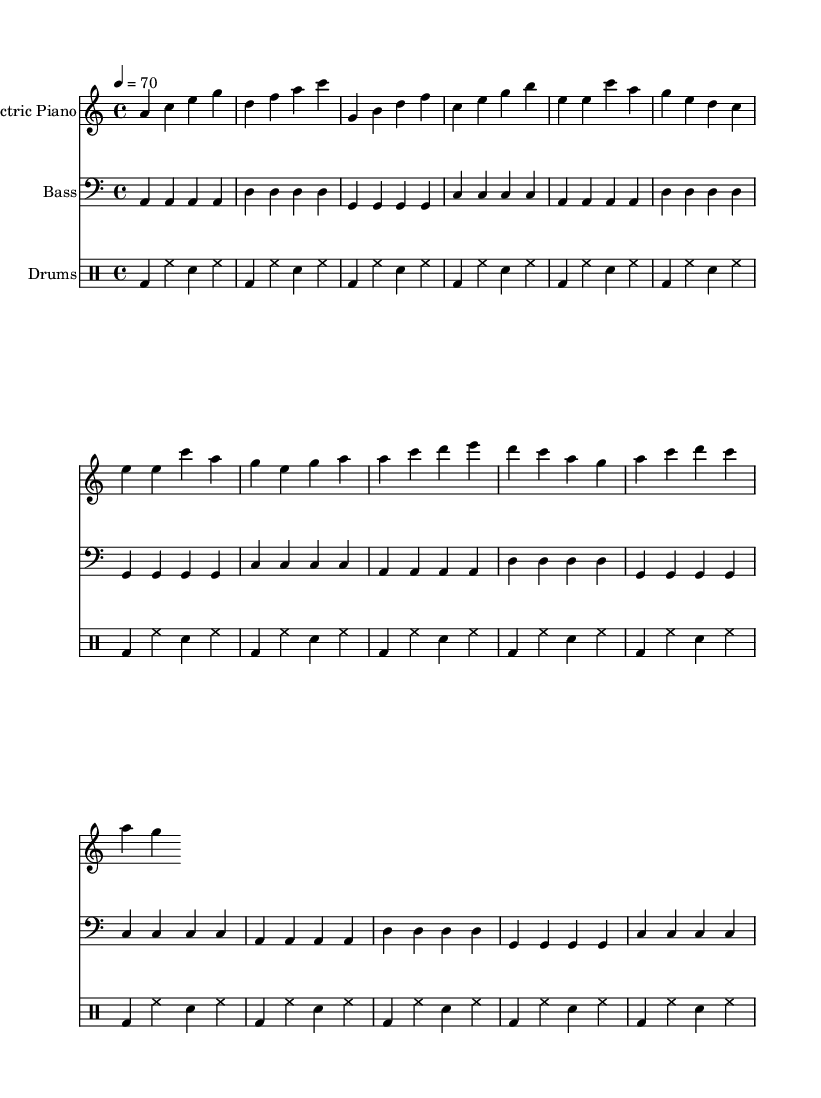What is the key signature of this music? The key signature is A minor, which has no sharps or flats.
Answer: A minor What is the time signature of the music? The time signature is 4/4, indicating four beats per measure.
Answer: 4/4 What is the tempo marking for this piece? The tempo marking is quarter note equals 70, meaning there are 70 beats in a minute.
Answer: 70 How many measures are in the verse section? The verse section contains 8 measures, as indicated by the notation in that part of the sheet music.
Answer: 8 What instrument plays the main melodic line in this piece? The electric piano plays the main melodic line, as it is shown prominently in the treble clef staff.
Answer: Electric Piano What rhythmic pattern do the drums primarily use? The drums use a basic 4-bar pattern of bass and snare with hi-hat, typical in R&B music, emphasizing the groove.
Answer: Bass and snare with hi-hat What chord progression is used in the intro section? The chord progression in the intro is A minor, D major, G major, and C major, which sets the mood for the R&B style.
Answer: A minor, D major, G major, C major 